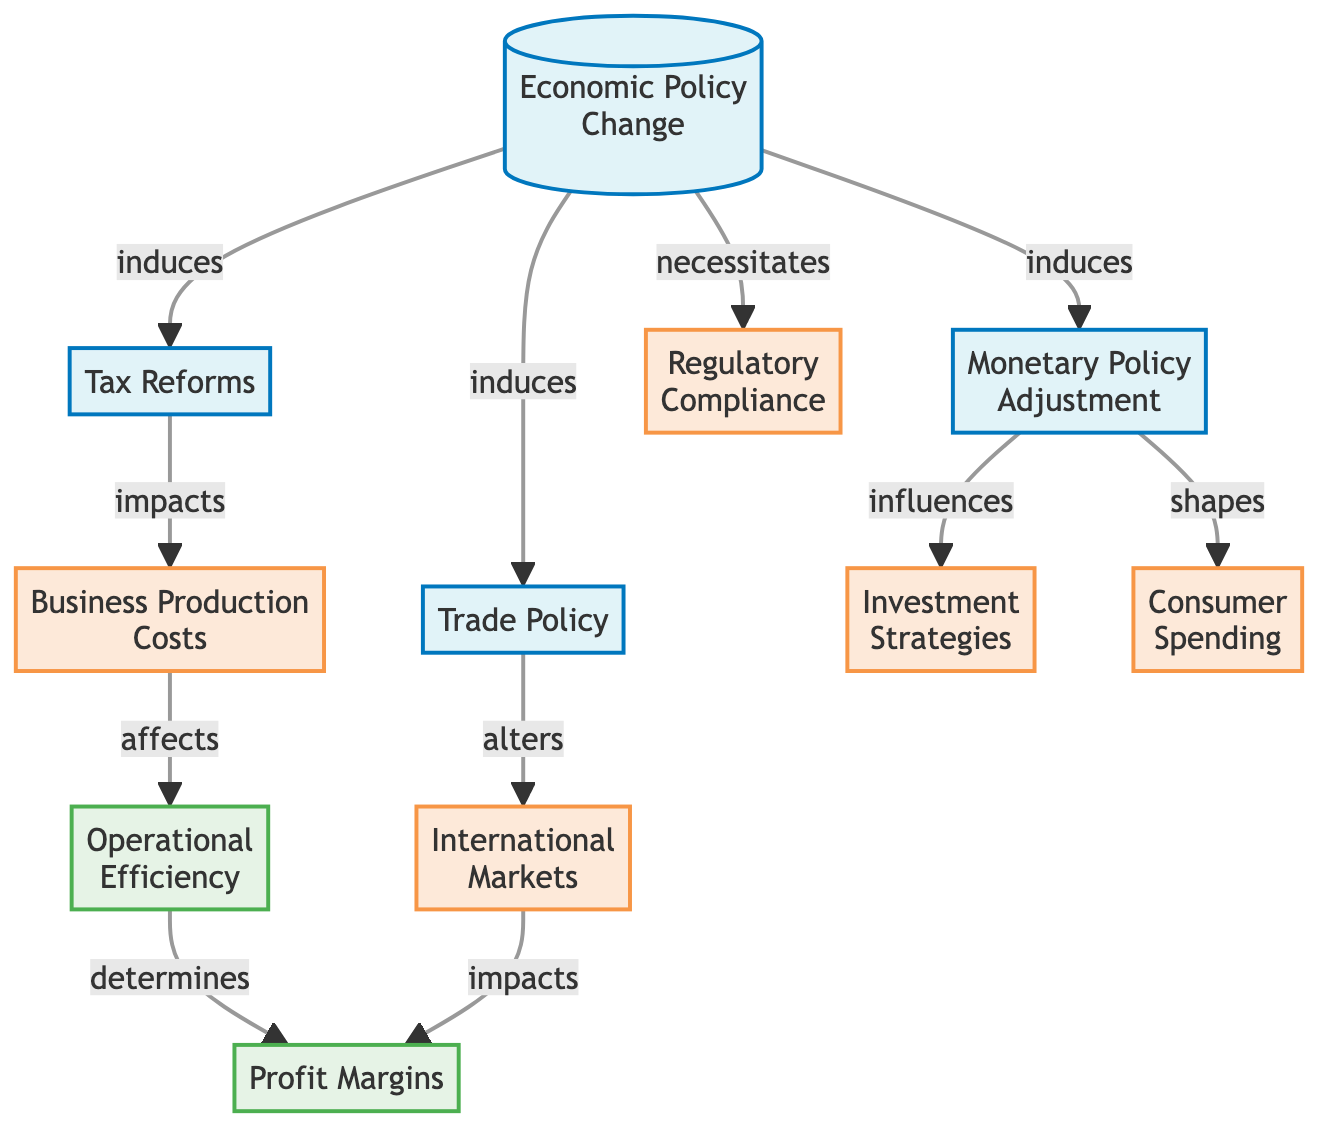What is the total number of nodes in the diagram? The diagram lists 11 distinct entities or concepts, each represented as a node. Counting each listed label, we find that there are 11 nodes: Economic Policy Change, Tax Reforms, Monetary Policy Adjustment, Trade Policy, Business Production Costs, Investment Strategies, International Markets, Consumer Spending, Regulatory Compliance, Operational Efficiency, and Profit Margins.
Answer: 11 What does the "Economic Policy Change" induce? The "Economic Policy Change" node has three outgoing edges that indicate it induces three other nodes: Tax Reforms, Monetary Policy Adjustment, and Trade Policy. Thus, the induced elements directly affected are these three.
Answer: Tax Reforms, Monetary Policy Adjustment, Trade Policy What type of relationship exists between "Monetary Policy Adjustment" and "Investment Strategies"? The edge indicates a directional flow from "Monetary Policy Adjustment" to "Investment Strategies" labeled as "influences". This implies that changes in monetary policy have an influence on how businesses adjust their investment strategies.
Answer: influences How many edges are present in the diagram? Analyzing the connections, there are a total of 10 edges that represent the relationships among the nodes. These edges show how the economic policies interact and impact various aspects of business operations.
Answer: 10 Which node is impacted by both "Business Production Costs" and "International Markets"? From the edges, we can trace that "Business Production Costs" affects "Operational Efficiency" and "International Markets" impacts "Profit Margins". However, "Profit Margins" is affected by "International Markets", so the node impacted by the influence of "International Markets" is "Profit Margins".
Answer: Profit Margins What is the last node affected by "Tax Reforms"? Tracing the edge from "Tax Reforms" to "Business Production Costs", it shows that it impacts this node. Following the flow, "Business Production Costs" affects "Operational Efficiency", leading to "Profit Margins" ultimately being influenced by it. Therefore, the last node impacted is "Profit Margins".
Answer: Profit Margins What necessitates "Regulatory Compliance"? The "Economic Policy Change" node directly leads to "Regulatory Compliance", showing that new economic policies create the need for businesses to comply with updated regulations. Hence, the necessity arises from this initial change.
Answer: Economic Policy Change Which economic policy change shapes "Consumer Spending"? The edge from "Monetary Policy Adjustment" to "Consumer Spending" indicates that adjustments in monetary policy directly shape consumer purchasing behavior, meaning the output in consumer spending correlates with such changes.
Answer: Monetary Policy Adjustment 